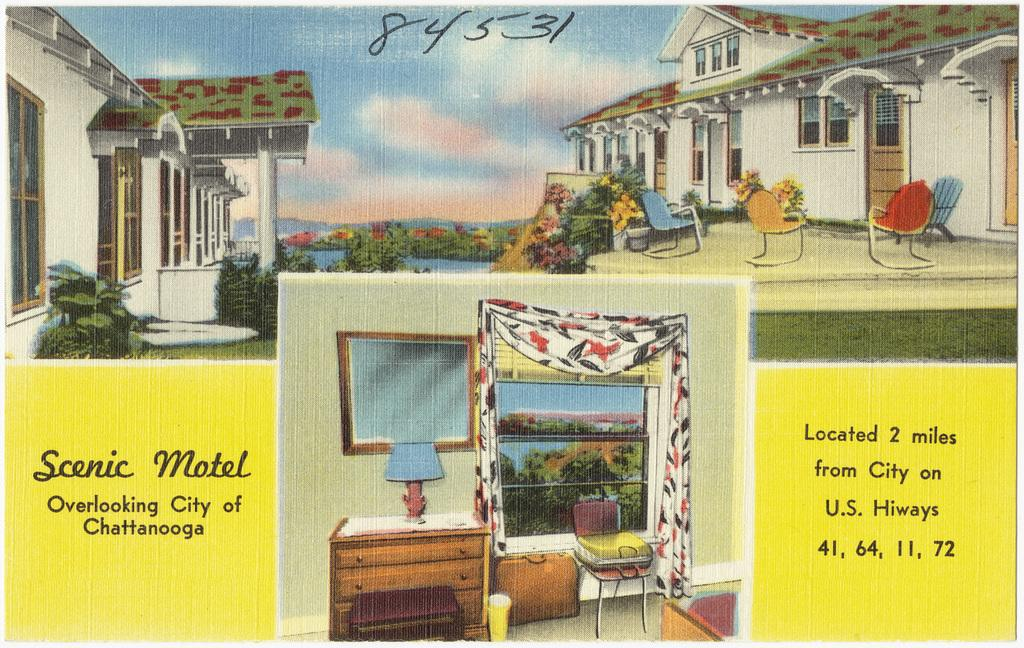What is depicted in the painting in the image? There is a painting of a motel in the image. What additional information is provided in the image? There is a descriptive note in the image. What types of pictures are included in the image? There are pictures of the motel inside and outside in the image. What type of bean is growing in the image? There are no beans present in the image; it features a painting of a motel and related pictures. How many clouds can be seen in the image? There are no clouds visible in the image, as it focuses on the motel and its pictures. 